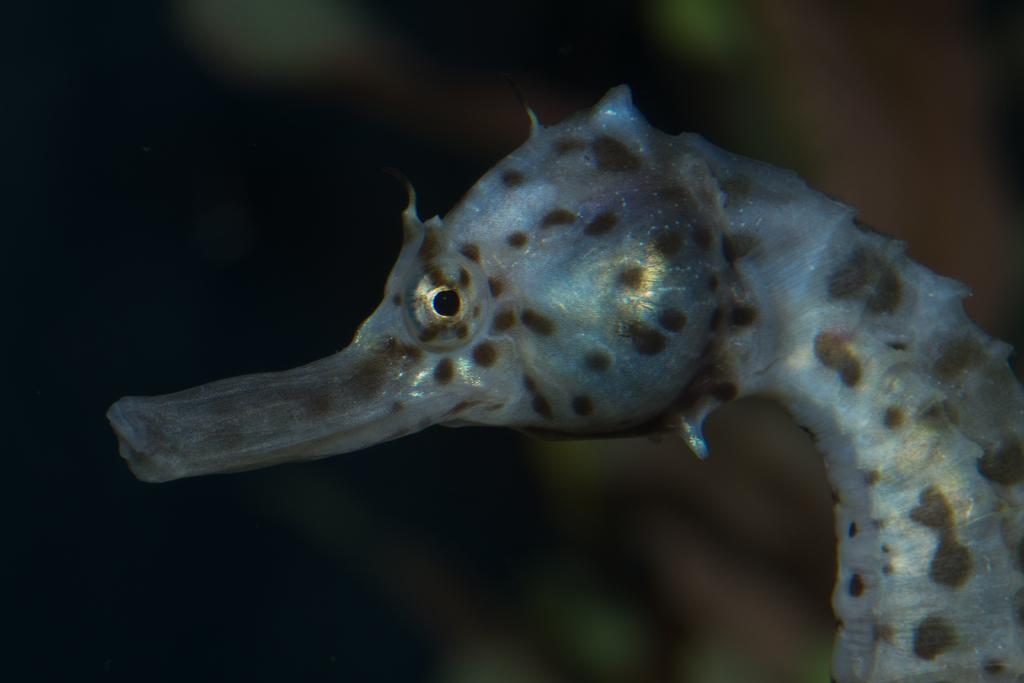What type of location is depicted in the image? The image consists of a seashore. What is the color scheme of the image? The image is in gray color. Can you describe the background of the image? The background of the image is blurred. How many cars can be seen in the image? There are no cars present in the image, as it depicts a seashore. What type of cub is visible in the image? There is no cub present in the image; it features a seashore with a gray color scheme and a blurred background. 